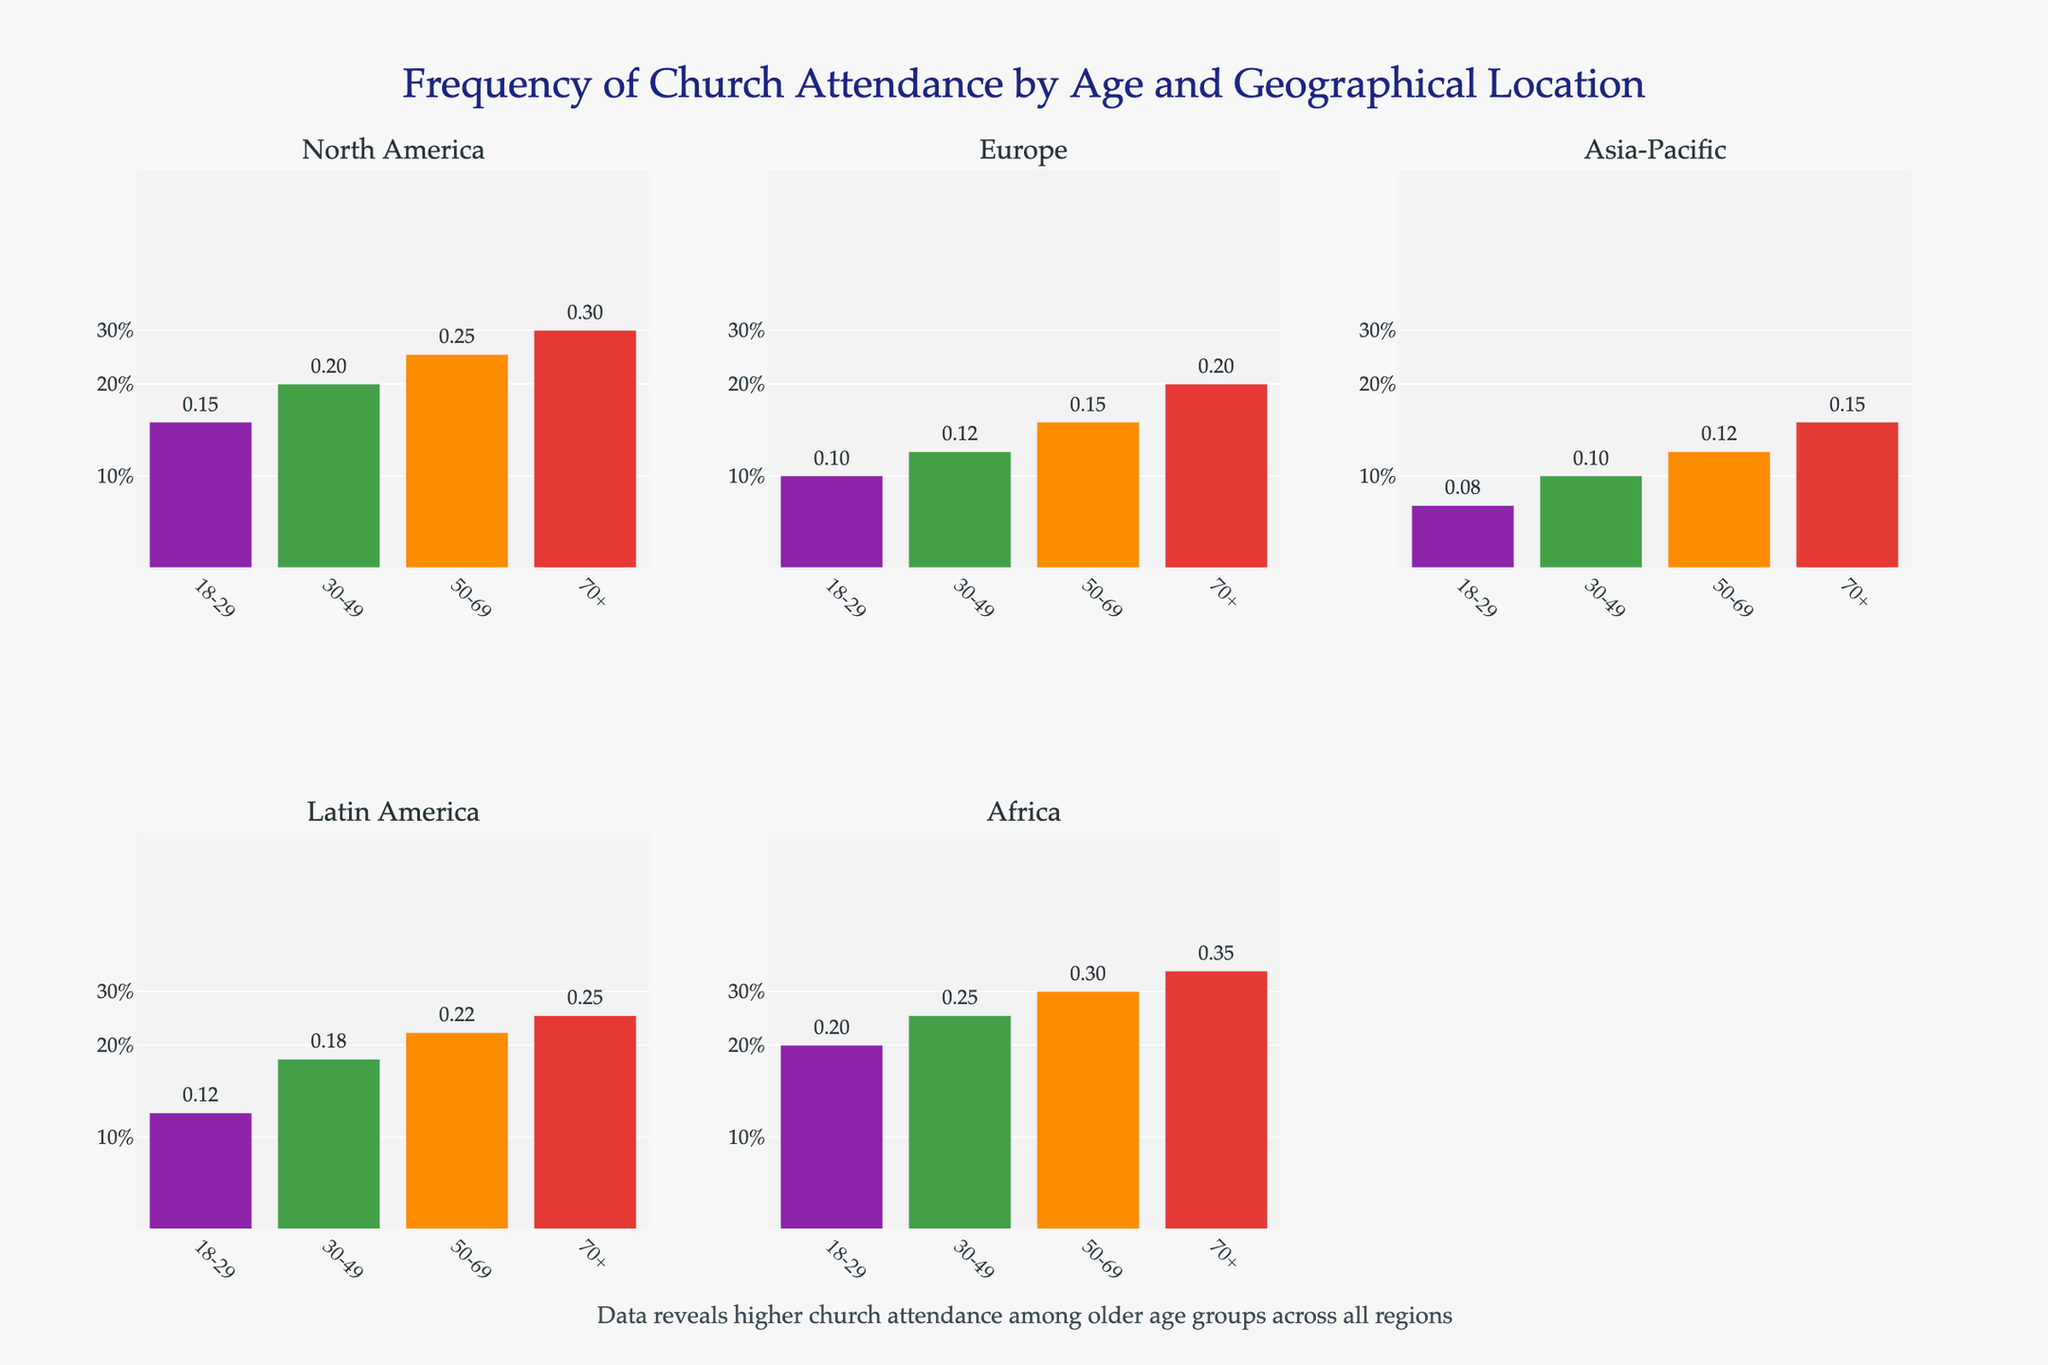Which age group has the highest church attendance in Africa? By examining the subplot for Africa, we can see the bars representing different age groups. The '70+' age group has the tallest bar, indicating the highest frequency of church attendance.
Answer: 70+ How does church attendance in Latin America for the age group 18-29 compare to that in Europe for the same age group? By comparing the height of the bars for the age group 18-29 in the subplots for Latin America and Europe, we can see that Latin America has a higher frequency (0.12) than Europe (0.1).
Answer: Latin America is higher What is the attendance frequency range shown on the plot? The y-axis is labeled with values of 0.1, 0.2, and 0.3, representing 10%, 20%, and 30% respectively. These are the frequencies are represented in the plot.
Answer: 10% to 30% Which region shows the lowest church attendance for the age group 30-49, and what is this frequency? By examining each subplot, we see that Europe has the lowest bar for the age group 30-49, with a frequency of 0.12.
Answer: Europe, 0.12 How does the annotation summarize the overall trend seen in the data? The annotation states that data reveals higher church attendance among older age groups across all regions. By looking at the bars in each subplot, we see that the frequency generally increases with age, confirming the annotation's summary.
Answer: Higher attendance among older age groups Which age group in North America has the smallest frequency of church attendance, and what is this frequency? By looking at the bars in the North America subplot, the 18-29 age group has the smallest bar with a frequency of 0.15.
Answer: 18-29, 0.15 What is the difference in church attendance frequency between the age groups 50-69 and 70+ in Asia-Pacific? By examining the subplot for Asia-Pacific, we see the bars for the age groups 50-69 and 70+. The difference in frequency is calculated as 0.15 (70+) - 0.12 (50-69) = 0.03.
Answer: 0.03 Which regions have a church attendance frequency of greater than or equal to 0.3 for the 70+ age group? By examining the subplots for each region, we see that North America and Africa have frequencies of 0.3 and 0.35 respectively for the 70+ age group.
Answer: North America, Africa 